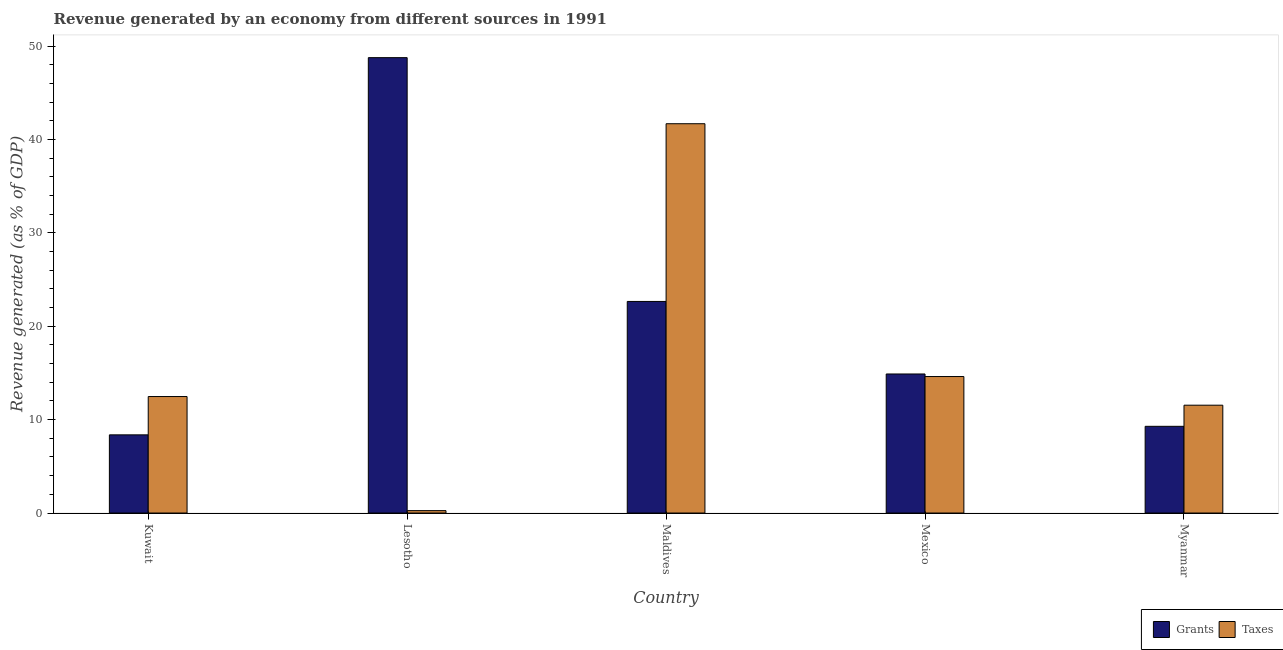Are the number of bars per tick equal to the number of legend labels?
Make the answer very short. Yes. How many bars are there on the 1st tick from the right?
Your response must be concise. 2. What is the label of the 2nd group of bars from the left?
Offer a terse response. Lesotho. What is the revenue generated by grants in Mexico?
Give a very brief answer. 14.89. Across all countries, what is the maximum revenue generated by taxes?
Give a very brief answer. 41.68. Across all countries, what is the minimum revenue generated by grants?
Ensure brevity in your answer.  8.37. In which country was the revenue generated by taxes maximum?
Your answer should be very brief. Maldives. In which country was the revenue generated by taxes minimum?
Provide a short and direct response. Lesotho. What is the total revenue generated by grants in the graph?
Provide a succinct answer. 103.96. What is the difference between the revenue generated by grants in Lesotho and that in Mexico?
Keep it short and to the point. 33.87. What is the difference between the revenue generated by grants in Mexico and the revenue generated by taxes in Maldives?
Offer a terse response. -26.8. What is the average revenue generated by grants per country?
Your response must be concise. 20.79. What is the difference between the revenue generated by taxes and revenue generated by grants in Mexico?
Ensure brevity in your answer.  -0.27. In how many countries, is the revenue generated by taxes greater than 36 %?
Ensure brevity in your answer.  1. What is the ratio of the revenue generated by taxes in Maldives to that in Mexico?
Make the answer very short. 2.85. What is the difference between the highest and the second highest revenue generated by taxes?
Ensure brevity in your answer.  27.07. What is the difference between the highest and the lowest revenue generated by grants?
Give a very brief answer. 40.39. What does the 1st bar from the left in Mexico represents?
Ensure brevity in your answer.  Grants. What does the 2nd bar from the right in Myanmar represents?
Provide a short and direct response. Grants. Where does the legend appear in the graph?
Give a very brief answer. Bottom right. What is the title of the graph?
Offer a very short reply. Revenue generated by an economy from different sources in 1991. Does "Girls" appear as one of the legend labels in the graph?
Provide a short and direct response. No. What is the label or title of the X-axis?
Your answer should be very brief. Country. What is the label or title of the Y-axis?
Provide a short and direct response. Revenue generated (as % of GDP). What is the Revenue generated (as % of GDP) of Grants in Kuwait?
Give a very brief answer. 8.37. What is the Revenue generated (as % of GDP) of Taxes in Kuwait?
Give a very brief answer. 12.47. What is the Revenue generated (as % of GDP) of Grants in Lesotho?
Give a very brief answer. 48.76. What is the Revenue generated (as % of GDP) of Taxes in Lesotho?
Your answer should be very brief. 0.26. What is the Revenue generated (as % of GDP) in Grants in Maldives?
Your response must be concise. 22.66. What is the Revenue generated (as % of GDP) of Taxes in Maldives?
Give a very brief answer. 41.68. What is the Revenue generated (as % of GDP) of Grants in Mexico?
Ensure brevity in your answer.  14.89. What is the Revenue generated (as % of GDP) in Taxes in Mexico?
Your response must be concise. 14.61. What is the Revenue generated (as % of GDP) of Grants in Myanmar?
Your response must be concise. 9.28. What is the Revenue generated (as % of GDP) in Taxes in Myanmar?
Offer a terse response. 11.55. Across all countries, what is the maximum Revenue generated (as % of GDP) in Grants?
Your response must be concise. 48.76. Across all countries, what is the maximum Revenue generated (as % of GDP) of Taxes?
Keep it short and to the point. 41.68. Across all countries, what is the minimum Revenue generated (as % of GDP) of Grants?
Your response must be concise. 8.37. Across all countries, what is the minimum Revenue generated (as % of GDP) in Taxes?
Your response must be concise. 0.26. What is the total Revenue generated (as % of GDP) of Grants in the graph?
Ensure brevity in your answer.  103.96. What is the total Revenue generated (as % of GDP) of Taxes in the graph?
Your response must be concise. 80.57. What is the difference between the Revenue generated (as % of GDP) in Grants in Kuwait and that in Lesotho?
Your response must be concise. -40.39. What is the difference between the Revenue generated (as % of GDP) in Taxes in Kuwait and that in Lesotho?
Give a very brief answer. 12.22. What is the difference between the Revenue generated (as % of GDP) of Grants in Kuwait and that in Maldives?
Make the answer very short. -14.28. What is the difference between the Revenue generated (as % of GDP) of Taxes in Kuwait and that in Maldives?
Ensure brevity in your answer.  -29.21. What is the difference between the Revenue generated (as % of GDP) of Grants in Kuwait and that in Mexico?
Your response must be concise. -6.52. What is the difference between the Revenue generated (as % of GDP) of Taxes in Kuwait and that in Mexico?
Give a very brief answer. -2.14. What is the difference between the Revenue generated (as % of GDP) of Grants in Kuwait and that in Myanmar?
Offer a terse response. -0.91. What is the difference between the Revenue generated (as % of GDP) in Taxes in Kuwait and that in Myanmar?
Offer a terse response. 0.93. What is the difference between the Revenue generated (as % of GDP) in Grants in Lesotho and that in Maldives?
Provide a succinct answer. 26.1. What is the difference between the Revenue generated (as % of GDP) in Taxes in Lesotho and that in Maldives?
Your answer should be very brief. -41.43. What is the difference between the Revenue generated (as % of GDP) of Grants in Lesotho and that in Mexico?
Your answer should be very brief. 33.87. What is the difference between the Revenue generated (as % of GDP) of Taxes in Lesotho and that in Mexico?
Give a very brief answer. -14.36. What is the difference between the Revenue generated (as % of GDP) of Grants in Lesotho and that in Myanmar?
Provide a succinct answer. 39.48. What is the difference between the Revenue generated (as % of GDP) in Taxes in Lesotho and that in Myanmar?
Your answer should be compact. -11.29. What is the difference between the Revenue generated (as % of GDP) of Grants in Maldives and that in Mexico?
Your answer should be compact. 7.77. What is the difference between the Revenue generated (as % of GDP) of Taxes in Maldives and that in Mexico?
Give a very brief answer. 27.07. What is the difference between the Revenue generated (as % of GDP) of Grants in Maldives and that in Myanmar?
Your answer should be compact. 13.37. What is the difference between the Revenue generated (as % of GDP) of Taxes in Maldives and that in Myanmar?
Make the answer very short. 30.14. What is the difference between the Revenue generated (as % of GDP) in Grants in Mexico and that in Myanmar?
Give a very brief answer. 5.6. What is the difference between the Revenue generated (as % of GDP) in Taxes in Mexico and that in Myanmar?
Offer a very short reply. 3.07. What is the difference between the Revenue generated (as % of GDP) in Grants in Kuwait and the Revenue generated (as % of GDP) in Taxes in Lesotho?
Make the answer very short. 8.12. What is the difference between the Revenue generated (as % of GDP) of Grants in Kuwait and the Revenue generated (as % of GDP) of Taxes in Maldives?
Keep it short and to the point. -33.31. What is the difference between the Revenue generated (as % of GDP) of Grants in Kuwait and the Revenue generated (as % of GDP) of Taxes in Mexico?
Your answer should be compact. -6.24. What is the difference between the Revenue generated (as % of GDP) in Grants in Kuwait and the Revenue generated (as % of GDP) in Taxes in Myanmar?
Make the answer very short. -3.17. What is the difference between the Revenue generated (as % of GDP) in Grants in Lesotho and the Revenue generated (as % of GDP) in Taxes in Maldives?
Offer a terse response. 7.08. What is the difference between the Revenue generated (as % of GDP) in Grants in Lesotho and the Revenue generated (as % of GDP) in Taxes in Mexico?
Ensure brevity in your answer.  34.15. What is the difference between the Revenue generated (as % of GDP) of Grants in Lesotho and the Revenue generated (as % of GDP) of Taxes in Myanmar?
Your answer should be compact. 37.21. What is the difference between the Revenue generated (as % of GDP) in Grants in Maldives and the Revenue generated (as % of GDP) in Taxes in Mexico?
Keep it short and to the point. 8.04. What is the difference between the Revenue generated (as % of GDP) of Grants in Maldives and the Revenue generated (as % of GDP) of Taxes in Myanmar?
Offer a terse response. 11.11. What is the difference between the Revenue generated (as % of GDP) of Grants in Mexico and the Revenue generated (as % of GDP) of Taxes in Myanmar?
Your answer should be very brief. 3.34. What is the average Revenue generated (as % of GDP) in Grants per country?
Give a very brief answer. 20.79. What is the average Revenue generated (as % of GDP) in Taxes per country?
Offer a very short reply. 16.11. What is the difference between the Revenue generated (as % of GDP) in Grants and Revenue generated (as % of GDP) in Taxes in Kuwait?
Ensure brevity in your answer.  -4.1. What is the difference between the Revenue generated (as % of GDP) in Grants and Revenue generated (as % of GDP) in Taxes in Lesotho?
Provide a succinct answer. 48.5. What is the difference between the Revenue generated (as % of GDP) in Grants and Revenue generated (as % of GDP) in Taxes in Maldives?
Make the answer very short. -19.03. What is the difference between the Revenue generated (as % of GDP) of Grants and Revenue generated (as % of GDP) of Taxes in Mexico?
Provide a succinct answer. 0.27. What is the difference between the Revenue generated (as % of GDP) of Grants and Revenue generated (as % of GDP) of Taxes in Myanmar?
Give a very brief answer. -2.26. What is the ratio of the Revenue generated (as % of GDP) in Grants in Kuwait to that in Lesotho?
Your answer should be compact. 0.17. What is the ratio of the Revenue generated (as % of GDP) of Taxes in Kuwait to that in Lesotho?
Provide a short and direct response. 48.8. What is the ratio of the Revenue generated (as % of GDP) of Grants in Kuwait to that in Maldives?
Your answer should be very brief. 0.37. What is the ratio of the Revenue generated (as % of GDP) in Taxes in Kuwait to that in Maldives?
Offer a very short reply. 0.3. What is the ratio of the Revenue generated (as % of GDP) in Grants in Kuwait to that in Mexico?
Your response must be concise. 0.56. What is the ratio of the Revenue generated (as % of GDP) of Taxes in Kuwait to that in Mexico?
Ensure brevity in your answer.  0.85. What is the ratio of the Revenue generated (as % of GDP) of Grants in Kuwait to that in Myanmar?
Ensure brevity in your answer.  0.9. What is the ratio of the Revenue generated (as % of GDP) in Taxes in Kuwait to that in Myanmar?
Keep it short and to the point. 1.08. What is the ratio of the Revenue generated (as % of GDP) of Grants in Lesotho to that in Maldives?
Your answer should be very brief. 2.15. What is the ratio of the Revenue generated (as % of GDP) in Taxes in Lesotho to that in Maldives?
Your response must be concise. 0.01. What is the ratio of the Revenue generated (as % of GDP) of Grants in Lesotho to that in Mexico?
Offer a terse response. 3.28. What is the ratio of the Revenue generated (as % of GDP) of Taxes in Lesotho to that in Mexico?
Make the answer very short. 0.02. What is the ratio of the Revenue generated (as % of GDP) in Grants in Lesotho to that in Myanmar?
Give a very brief answer. 5.25. What is the ratio of the Revenue generated (as % of GDP) in Taxes in Lesotho to that in Myanmar?
Provide a short and direct response. 0.02. What is the ratio of the Revenue generated (as % of GDP) in Grants in Maldives to that in Mexico?
Give a very brief answer. 1.52. What is the ratio of the Revenue generated (as % of GDP) of Taxes in Maldives to that in Mexico?
Make the answer very short. 2.85. What is the ratio of the Revenue generated (as % of GDP) of Grants in Maldives to that in Myanmar?
Provide a succinct answer. 2.44. What is the ratio of the Revenue generated (as % of GDP) in Taxes in Maldives to that in Myanmar?
Ensure brevity in your answer.  3.61. What is the ratio of the Revenue generated (as % of GDP) of Grants in Mexico to that in Myanmar?
Your response must be concise. 1.6. What is the ratio of the Revenue generated (as % of GDP) of Taxes in Mexico to that in Myanmar?
Your answer should be compact. 1.27. What is the difference between the highest and the second highest Revenue generated (as % of GDP) in Grants?
Make the answer very short. 26.1. What is the difference between the highest and the second highest Revenue generated (as % of GDP) in Taxes?
Your answer should be compact. 27.07. What is the difference between the highest and the lowest Revenue generated (as % of GDP) of Grants?
Give a very brief answer. 40.39. What is the difference between the highest and the lowest Revenue generated (as % of GDP) of Taxes?
Keep it short and to the point. 41.43. 